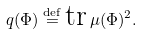<formula> <loc_0><loc_0><loc_500><loc_500>q ( \Phi ) \overset { \text {def} } { = } \text {tr} \, \mu ( \Phi ) ^ { 2 } .</formula> 